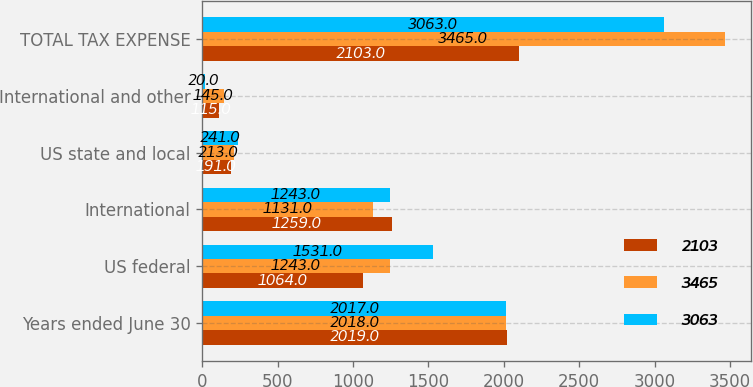<chart> <loc_0><loc_0><loc_500><loc_500><stacked_bar_chart><ecel><fcel>Years ended June 30<fcel>US federal<fcel>International<fcel>US state and local<fcel>International and other<fcel>TOTAL TAX EXPENSE<nl><fcel>2103<fcel>2019<fcel>1064<fcel>1259<fcel>191<fcel>115<fcel>2103<nl><fcel>3465<fcel>2018<fcel>1243<fcel>1131<fcel>213<fcel>145<fcel>3465<nl><fcel>3063<fcel>2017<fcel>1531<fcel>1243<fcel>241<fcel>20<fcel>3063<nl></chart> 